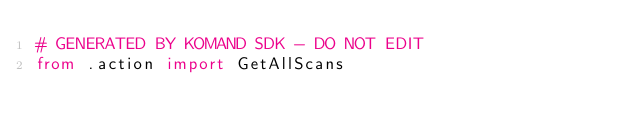<code> <loc_0><loc_0><loc_500><loc_500><_Python_># GENERATED BY KOMAND SDK - DO NOT EDIT
from .action import GetAllScans
</code> 